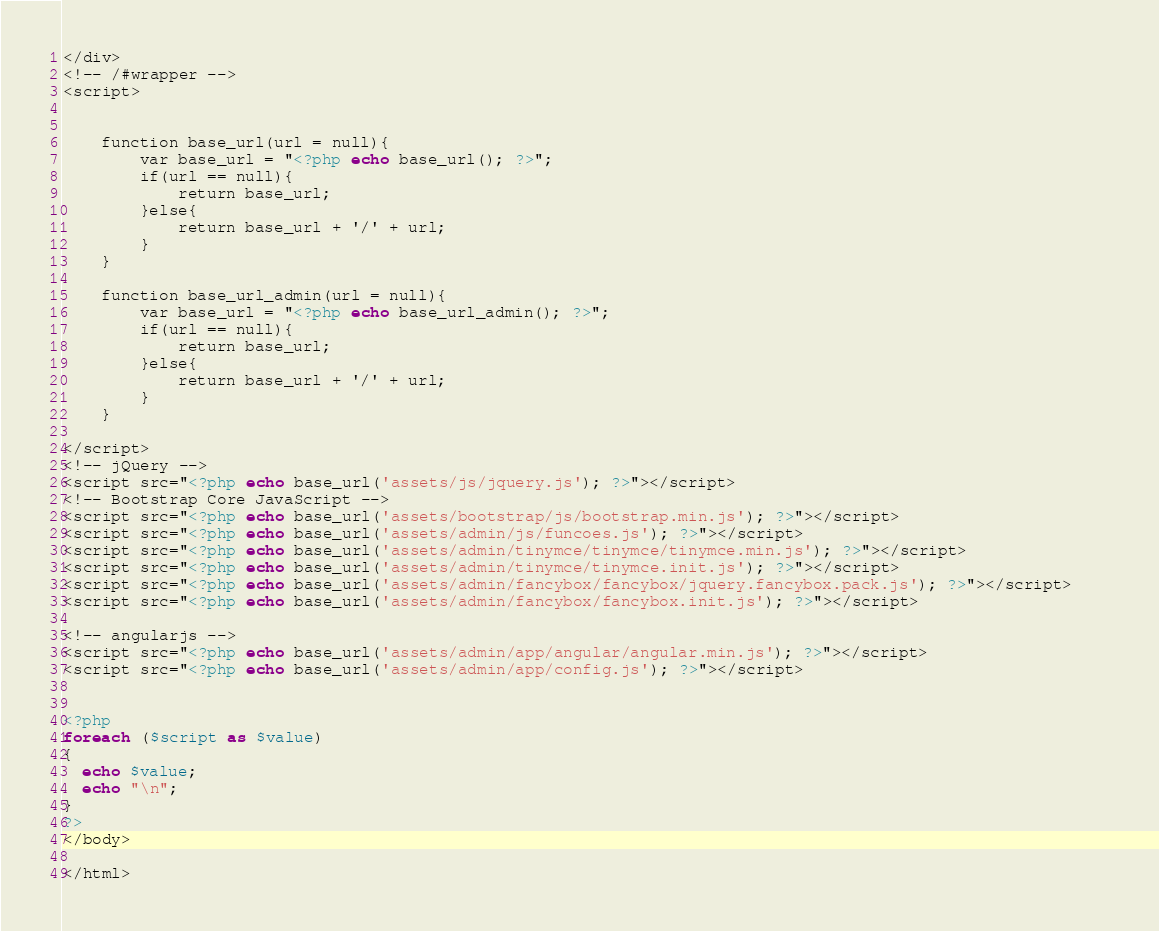<code> <loc_0><loc_0><loc_500><loc_500><_PHP_></div>
<!-- /#wrapper -->
<script>
    
    
    function base_url(url = null){
        var base_url = "<?php echo base_url(); ?>";
        if(url == null){
            return base_url;
        }else{
            return base_url + '/' + url;
        }
    }
    
    function base_url_admin(url = null){
        var base_url = "<?php echo base_url_admin(); ?>";
        if(url == null){
            return base_url;
        }else{
            return base_url + '/' + url;
        }
    }
    
</script>
<!-- jQuery -->
<script src="<?php echo base_url('assets/js/jquery.js'); ?>"></script>
<!-- Bootstrap Core JavaScript -->
<script src="<?php echo base_url('assets/bootstrap/js/bootstrap.min.js'); ?>"></script>
<script src="<?php echo base_url('assets/admin/js/funcoes.js'); ?>"></script>	
<script src="<?php echo base_url('assets/admin/tinymce/tinymce/tinymce.min.js'); ?>"></script>	
<script src="<?php echo base_url('assets/admin/tinymce/tinymce.init.js'); ?>"></script>	
<script src="<?php echo base_url('assets/admin/fancybox/fancybox/jquery.fancybox.pack.js'); ?>"></script>	
<script src="<?php echo base_url('assets/admin/fancybox/fancybox.init.js'); ?>"></script>

<!-- angularjs -->
<script src="<?php echo base_url('assets/admin/app/angular/angular.min.js'); ?>"></script>
<script src="<?php echo base_url('assets/admin/app/config.js'); ?>"></script>


<?php
foreach ($script as $value)
{
  echo $value;
  echo "\n";
}
?>
</body>

</html>
</code> 